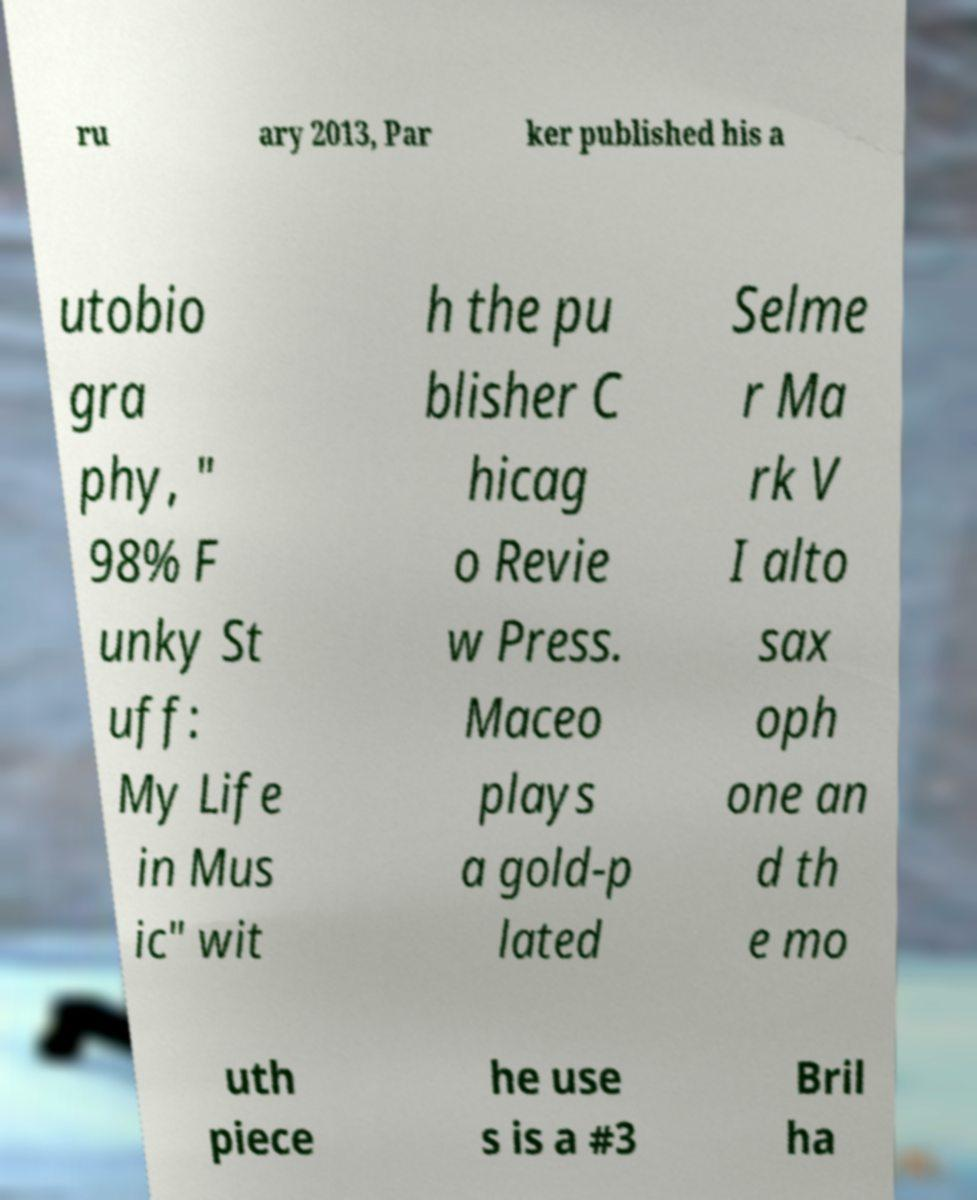There's text embedded in this image that I need extracted. Can you transcribe it verbatim? ru ary 2013, Par ker published his a utobio gra phy, " 98% F unky St uff: My Life in Mus ic" wit h the pu blisher C hicag o Revie w Press. Maceo plays a gold-p lated Selme r Ma rk V I alto sax oph one an d th e mo uth piece he use s is a #3 Bril ha 